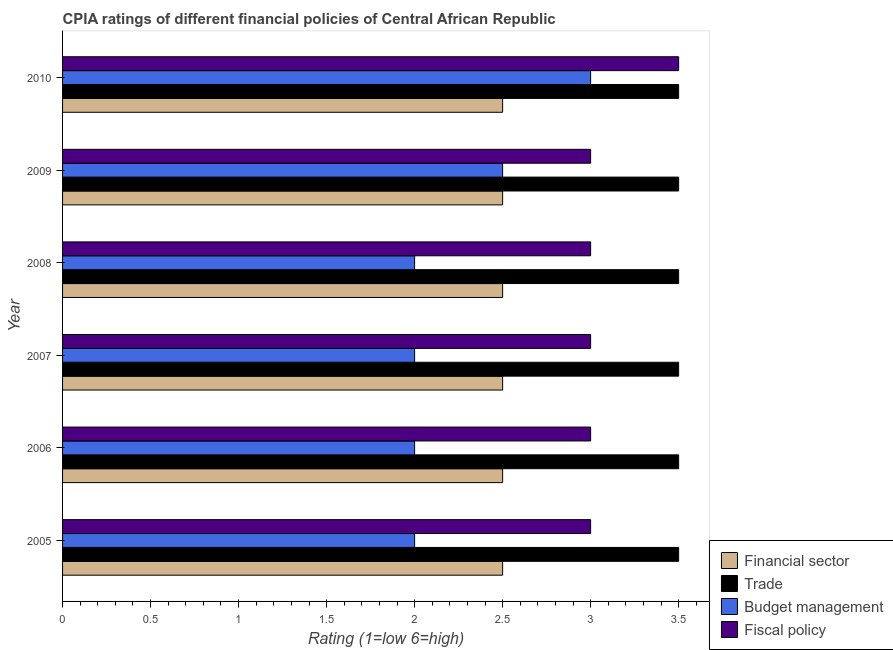How many different coloured bars are there?
Your answer should be compact. 4. Are the number of bars on each tick of the Y-axis equal?
Give a very brief answer. Yes. How many bars are there on the 4th tick from the bottom?
Keep it short and to the point. 4. What is the cpia rating of fiscal policy in 2007?
Ensure brevity in your answer.  3. In which year was the cpia rating of trade minimum?
Make the answer very short. 2005. What is the total cpia rating of trade in the graph?
Your answer should be very brief. 21. What is the difference between the cpia rating of trade in 2009 and the cpia rating of budget management in 2007?
Provide a short and direct response. 1.5. What is the average cpia rating of fiscal policy per year?
Give a very brief answer. 3.08. What is the ratio of the cpia rating of financial sector in 2005 to that in 2007?
Make the answer very short. 1. What is the difference between the highest and the second highest cpia rating of budget management?
Ensure brevity in your answer.  0.5. Is the sum of the cpia rating of trade in 2006 and 2007 greater than the maximum cpia rating of financial sector across all years?
Your answer should be compact. Yes. What does the 2nd bar from the top in 2009 represents?
Give a very brief answer. Budget management. What does the 2nd bar from the bottom in 2007 represents?
Offer a very short reply. Trade. How many bars are there?
Provide a short and direct response. 24. What is the difference between two consecutive major ticks on the X-axis?
Give a very brief answer. 0.5. Where does the legend appear in the graph?
Make the answer very short. Bottom right. How many legend labels are there?
Keep it short and to the point. 4. What is the title of the graph?
Your response must be concise. CPIA ratings of different financial policies of Central African Republic. Does "Secondary vocational" appear as one of the legend labels in the graph?
Give a very brief answer. No. What is the label or title of the Y-axis?
Offer a very short reply. Year. What is the Rating (1=low 6=high) of Trade in 2005?
Ensure brevity in your answer.  3.5. What is the Rating (1=low 6=high) in Fiscal policy in 2005?
Give a very brief answer. 3. What is the Rating (1=low 6=high) in Financial sector in 2006?
Offer a terse response. 2.5. What is the Rating (1=low 6=high) in Trade in 2006?
Offer a terse response. 3.5. What is the Rating (1=low 6=high) of Budget management in 2006?
Give a very brief answer. 2. What is the Rating (1=low 6=high) of Financial sector in 2007?
Offer a terse response. 2.5. What is the Rating (1=low 6=high) in Budget management in 2007?
Keep it short and to the point. 2. What is the Rating (1=low 6=high) in Budget management in 2008?
Offer a terse response. 2. What is the Rating (1=low 6=high) of Fiscal policy in 2009?
Ensure brevity in your answer.  3. What is the Rating (1=low 6=high) in Trade in 2010?
Provide a short and direct response. 3.5. Across all years, what is the maximum Rating (1=low 6=high) in Financial sector?
Provide a short and direct response. 2.5. Across all years, what is the maximum Rating (1=low 6=high) of Budget management?
Provide a succinct answer. 3. Across all years, what is the minimum Rating (1=low 6=high) of Budget management?
Your response must be concise. 2. What is the total Rating (1=low 6=high) in Trade in the graph?
Keep it short and to the point. 21. What is the total Rating (1=low 6=high) in Budget management in the graph?
Your answer should be very brief. 13.5. What is the difference between the Rating (1=low 6=high) of Financial sector in 2005 and that in 2006?
Keep it short and to the point. 0. What is the difference between the Rating (1=low 6=high) of Fiscal policy in 2005 and that in 2006?
Give a very brief answer. 0. What is the difference between the Rating (1=low 6=high) in Financial sector in 2005 and that in 2007?
Provide a succinct answer. 0. What is the difference between the Rating (1=low 6=high) of Trade in 2005 and that in 2007?
Offer a very short reply. 0. What is the difference between the Rating (1=low 6=high) of Budget management in 2005 and that in 2007?
Provide a short and direct response. 0. What is the difference between the Rating (1=low 6=high) of Trade in 2005 and that in 2008?
Provide a short and direct response. 0. What is the difference between the Rating (1=low 6=high) of Budget management in 2005 and that in 2008?
Provide a short and direct response. 0. What is the difference between the Rating (1=low 6=high) of Fiscal policy in 2005 and that in 2008?
Your answer should be very brief. 0. What is the difference between the Rating (1=low 6=high) in Financial sector in 2005 and that in 2010?
Offer a very short reply. 0. What is the difference between the Rating (1=low 6=high) in Budget management in 2005 and that in 2010?
Your answer should be very brief. -1. What is the difference between the Rating (1=low 6=high) in Financial sector in 2006 and that in 2007?
Make the answer very short. 0. What is the difference between the Rating (1=low 6=high) of Budget management in 2006 and that in 2007?
Your response must be concise. 0. What is the difference between the Rating (1=low 6=high) of Fiscal policy in 2006 and that in 2007?
Ensure brevity in your answer.  0. What is the difference between the Rating (1=low 6=high) in Trade in 2006 and that in 2008?
Provide a succinct answer. 0. What is the difference between the Rating (1=low 6=high) of Budget management in 2006 and that in 2008?
Your answer should be compact. 0. What is the difference between the Rating (1=low 6=high) of Trade in 2006 and that in 2009?
Offer a very short reply. 0. What is the difference between the Rating (1=low 6=high) in Budget management in 2006 and that in 2009?
Offer a very short reply. -0.5. What is the difference between the Rating (1=low 6=high) in Financial sector in 2006 and that in 2010?
Make the answer very short. 0. What is the difference between the Rating (1=low 6=high) of Financial sector in 2007 and that in 2008?
Your answer should be very brief. 0. What is the difference between the Rating (1=low 6=high) of Trade in 2007 and that in 2008?
Offer a terse response. 0. What is the difference between the Rating (1=low 6=high) of Budget management in 2007 and that in 2008?
Offer a terse response. 0. What is the difference between the Rating (1=low 6=high) in Trade in 2007 and that in 2009?
Keep it short and to the point. 0. What is the difference between the Rating (1=low 6=high) of Budget management in 2007 and that in 2009?
Keep it short and to the point. -0.5. What is the difference between the Rating (1=low 6=high) in Fiscal policy in 2007 and that in 2009?
Offer a terse response. 0. What is the difference between the Rating (1=low 6=high) of Fiscal policy in 2007 and that in 2010?
Your answer should be very brief. -0.5. What is the difference between the Rating (1=low 6=high) in Trade in 2008 and that in 2009?
Provide a short and direct response. 0. What is the difference between the Rating (1=low 6=high) of Budget management in 2008 and that in 2009?
Your response must be concise. -0.5. What is the difference between the Rating (1=low 6=high) in Fiscal policy in 2008 and that in 2009?
Make the answer very short. 0. What is the difference between the Rating (1=low 6=high) of Financial sector in 2008 and that in 2010?
Offer a very short reply. 0. What is the difference between the Rating (1=low 6=high) of Trade in 2008 and that in 2010?
Ensure brevity in your answer.  0. What is the difference between the Rating (1=low 6=high) in Financial sector in 2009 and that in 2010?
Make the answer very short. 0. What is the difference between the Rating (1=low 6=high) in Trade in 2009 and that in 2010?
Ensure brevity in your answer.  0. What is the difference between the Rating (1=low 6=high) of Budget management in 2009 and that in 2010?
Your answer should be compact. -0.5. What is the difference between the Rating (1=low 6=high) of Fiscal policy in 2009 and that in 2010?
Offer a terse response. -0.5. What is the difference between the Rating (1=low 6=high) in Financial sector in 2005 and the Rating (1=low 6=high) in Budget management in 2006?
Make the answer very short. 0.5. What is the difference between the Rating (1=low 6=high) in Trade in 2005 and the Rating (1=low 6=high) in Fiscal policy in 2006?
Your answer should be very brief. 0.5. What is the difference between the Rating (1=low 6=high) of Trade in 2005 and the Rating (1=low 6=high) of Fiscal policy in 2007?
Give a very brief answer. 0.5. What is the difference between the Rating (1=low 6=high) in Budget management in 2005 and the Rating (1=low 6=high) in Fiscal policy in 2007?
Your answer should be compact. -1. What is the difference between the Rating (1=low 6=high) of Financial sector in 2005 and the Rating (1=low 6=high) of Trade in 2008?
Ensure brevity in your answer.  -1. What is the difference between the Rating (1=low 6=high) of Financial sector in 2005 and the Rating (1=low 6=high) of Fiscal policy in 2008?
Offer a terse response. -0.5. What is the difference between the Rating (1=low 6=high) of Trade in 2005 and the Rating (1=low 6=high) of Budget management in 2008?
Your response must be concise. 1.5. What is the difference between the Rating (1=low 6=high) of Budget management in 2005 and the Rating (1=low 6=high) of Fiscal policy in 2008?
Offer a terse response. -1. What is the difference between the Rating (1=low 6=high) of Financial sector in 2005 and the Rating (1=low 6=high) of Budget management in 2009?
Your response must be concise. 0. What is the difference between the Rating (1=low 6=high) of Financial sector in 2005 and the Rating (1=low 6=high) of Fiscal policy in 2009?
Give a very brief answer. -0.5. What is the difference between the Rating (1=low 6=high) of Trade in 2005 and the Rating (1=low 6=high) of Budget management in 2009?
Your answer should be very brief. 1. What is the difference between the Rating (1=low 6=high) of Budget management in 2005 and the Rating (1=low 6=high) of Fiscal policy in 2009?
Offer a terse response. -1. What is the difference between the Rating (1=low 6=high) of Financial sector in 2005 and the Rating (1=low 6=high) of Fiscal policy in 2010?
Your response must be concise. -1. What is the difference between the Rating (1=low 6=high) of Trade in 2005 and the Rating (1=low 6=high) of Budget management in 2010?
Your response must be concise. 0.5. What is the difference between the Rating (1=low 6=high) of Financial sector in 2006 and the Rating (1=low 6=high) of Trade in 2007?
Provide a succinct answer. -1. What is the difference between the Rating (1=low 6=high) in Financial sector in 2006 and the Rating (1=low 6=high) in Budget management in 2007?
Provide a succinct answer. 0.5. What is the difference between the Rating (1=low 6=high) of Financial sector in 2006 and the Rating (1=low 6=high) of Fiscal policy in 2007?
Your answer should be very brief. -0.5. What is the difference between the Rating (1=low 6=high) in Trade in 2006 and the Rating (1=low 6=high) in Budget management in 2007?
Keep it short and to the point. 1.5. What is the difference between the Rating (1=low 6=high) of Budget management in 2006 and the Rating (1=low 6=high) of Fiscal policy in 2007?
Give a very brief answer. -1. What is the difference between the Rating (1=low 6=high) in Financial sector in 2006 and the Rating (1=low 6=high) in Trade in 2008?
Your answer should be very brief. -1. What is the difference between the Rating (1=low 6=high) in Financial sector in 2006 and the Rating (1=low 6=high) in Budget management in 2008?
Your answer should be compact. 0.5. What is the difference between the Rating (1=low 6=high) of Financial sector in 2006 and the Rating (1=low 6=high) of Fiscal policy in 2008?
Provide a short and direct response. -0.5. What is the difference between the Rating (1=low 6=high) in Trade in 2006 and the Rating (1=low 6=high) in Fiscal policy in 2008?
Your answer should be very brief. 0.5. What is the difference between the Rating (1=low 6=high) of Budget management in 2006 and the Rating (1=low 6=high) of Fiscal policy in 2008?
Your answer should be very brief. -1. What is the difference between the Rating (1=low 6=high) in Trade in 2006 and the Rating (1=low 6=high) in Budget management in 2009?
Ensure brevity in your answer.  1. What is the difference between the Rating (1=low 6=high) of Trade in 2006 and the Rating (1=low 6=high) of Fiscal policy in 2009?
Keep it short and to the point. 0.5. What is the difference between the Rating (1=low 6=high) in Budget management in 2006 and the Rating (1=low 6=high) in Fiscal policy in 2010?
Your response must be concise. -1.5. What is the difference between the Rating (1=low 6=high) in Financial sector in 2007 and the Rating (1=low 6=high) in Trade in 2008?
Give a very brief answer. -1. What is the difference between the Rating (1=low 6=high) in Financial sector in 2007 and the Rating (1=low 6=high) in Budget management in 2008?
Your response must be concise. 0.5. What is the difference between the Rating (1=low 6=high) in Financial sector in 2007 and the Rating (1=low 6=high) in Fiscal policy in 2008?
Offer a very short reply. -0.5. What is the difference between the Rating (1=low 6=high) in Trade in 2007 and the Rating (1=low 6=high) in Budget management in 2008?
Provide a succinct answer. 1.5. What is the difference between the Rating (1=low 6=high) in Trade in 2007 and the Rating (1=low 6=high) in Fiscal policy in 2008?
Provide a succinct answer. 0.5. What is the difference between the Rating (1=low 6=high) of Budget management in 2007 and the Rating (1=low 6=high) of Fiscal policy in 2008?
Offer a terse response. -1. What is the difference between the Rating (1=low 6=high) of Financial sector in 2007 and the Rating (1=low 6=high) of Trade in 2009?
Ensure brevity in your answer.  -1. What is the difference between the Rating (1=low 6=high) of Financial sector in 2007 and the Rating (1=low 6=high) of Budget management in 2009?
Provide a succinct answer. 0. What is the difference between the Rating (1=low 6=high) in Financial sector in 2007 and the Rating (1=low 6=high) in Fiscal policy in 2009?
Make the answer very short. -0.5. What is the difference between the Rating (1=low 6=high) of Trade in 2007 and the Rating (1=low 6=high) of Budget management in 2009?
Offer a terse response. 1. What is the difference between the Rating (1=low 6=high) of Budget management in 2007 and the Rating (1=low 6=high) of Fiscal policy in 2009?
Your answer should be very brief. -1. What is the difference between the Rating (1=low 6=high) in Financial sector in 2007 and the Rating (1=low 6=high) in Trade in 2010?
Ensure brevity in your answer.  -1. What is the difference between the Rating (1=low 6=high) of Financial sector in 2007 and the Rating (1=low 6=high) of Fiscal policy in 2010?
Provide a succinct answer. -1. What is the difference between the Rating (1=low 6=high) of Trade in 2007 and the Rating (1=low 6=high) of Budget management in 2010?
Your answer should be very brief. 0.5. What is the difference between the Rating (1=low 6=high) of Budget management in 2007 and the Rating (1=low 6=high) of Fiscal policy in 2010?
Ensure brevity in your answer.  -1.5. What is the difference between the Rating (1=low 6=high) in Financial sector in 2008 and the Rating (1=low 6=high) in Fiscal policy in 2009?
Make the answer very short. -0.5. What is the difference between the Rating (1=low 6=high) of Trade in 2008 and the Rating (1=low 6=high) of Budget management in 2009?
Give a very brief answer. 1. What is the difference between the Rating (1=low 6=high) in Trade in 2008 and the Rating (1=low 6=high) in Fiscal policy in 2009?
Your response must be concise. 0.5. What is the difference between the Rating (1=low 6=high) in Financial sector in 2008 and the Rating (1=low 6=high) in Trade in 2010?
Give a very brief answer. -1. What is the difference between the Rating (1=low 6=high) of Financial sector in 2008 and the Rating (1=low 6=high) of Budget management in 2010?
Give a very brief answer. -0.5. What is the difference between the Rating (1=low 6=high) of Financial sector in 2008 and the Rating (1=low 6=high) of Fiscal policy in 2010?
Your response must be concise. -1. What is the difference between the Rating (1=low 6=high) of Financial sector in 2009 and the Rating (1=low 6=high) of Budget management in 2010?
Make the answer very short. -0.5. What is the difference between the Rating (1=low 6=high) of Budget management in 2009 and the Rating (1=low 6=high) of Fiscal policy in 2010?
Offer a terse response. -1. What is the average Rating (1=low 6=high) of Trade per year?
Your answer should be compact. 3.5. What is the average Rating (1=low 6=high) of Budget management per year?
Your answer should be very brief. 2.25. What is the average Rating (1=low 6=high) of Fiscal policy per year?
Your response must be concise. 3.08. In the year 2005, what is the difference between the Rating (1=low 6=high) in Financial sector and Rating (1=low 6=high) in Trade?
Ensure brevity in your answer.  -1. In the year 2005, what is the difference between the Rating (1=low 6=high) of Financial sector and Rating (1=low 6=high) of Fiscal policy?
Ensure brevity in your answer.  -0.5. In the year 2005, what is the difference between the Rating (1=low 6=high) of Trade and Rating (1=low 6=high) of Budget management?
Your answer should be very brief. 1.5. In the year 2005, what is the difference between the Rating (1=low 6=high) in Trade and Rating (1=low 6=high) in Fiscal policy?
Offer a very short reply. 0.5. In the year 2005, what is the difference between the Rating (1=low 6=high) in Budget management and Rating (1=low 6=high) in Fiscal policy?
Your response must be concise. -1. In the year 2006, what is the difference between the Rating (1=low 6=high) in Financial sector and Rating (1=low 6=high) in Trade?
Your answer should be compact. -1. In the year 2006, what is the difference between the Rating (1=low 6=high) in Financial sector and Rating (1=low 6=high) in Budget management?
Give a very brief answer. 0.5. In the year 2006, what is the difference between the Rating (1=low 6=high) of Financial sector and Rating (1=low 6=high) of Fiscal policy?
Give a very brief answer. -0.5. In the year 2006, what is the difference between the Rating (1=low 6=high) of Budget management and Rating (1=low 6=high) of Fiscal policy?
Offer a very short reply. -1. In the year 2007, what is the difference between the Rating (1=low 6=high) in Financial sector and Rating (1=low 6=high) in Trade?
Your answer should be very brief. -1. In the year 2007, what is the difference between the Rating (1=low 6=high) of Financial sector and Rating (1=low 6=high) of Budget management?
Keep it short and to the point. 0.5. In the year 2008, what is the difference between the Rating (1=low 6=high) in Financial sector and Rating (1=low 6=high) in Trade?
Offer a very short reply. -1. In the year 2008, what is the difference between the Rating (1=low 6=high) in Financial sector and Rating (1=low 6=high) in Fiscal policy?
Keep it short and to the point. -0.5. In the year 2009, what is the difference between the Rating (1=low 6=high) in Financial sector and Rating (1=low 6=high) in Budget management?
Your response must be concise. 0. In the year 2009, what is the difference between the Rating (1=low 6=high) in Financial sector and Rating (1=low 6=high) in Fiscal policy?
Offer a terse response. -0.5. In the year 2009, what is the difference between the Rating (1=low 6=high) in Trade and Rating (1=low 6=high) in Budget management?
Your response must be concise. 1. In the year 2010, what is the difference between the Rating (1=low 6=high) in Financial sector and Rating (1=low 6=high) in Trade?
Make the answer very short. -1. In the year 2010, what is the difference between the Rating (1=low 6=high) of Financial sector and Rating (1=low 6=high) of Fiscal policy?
Provide a succinct answer. -1. In the year 2010, what is the difference between the Rating (1=low 6=high) of Trade and Rating (1=low 6=high) of Budget management?
Make the answer very short. 0.5. In the year 2010, what is the difference between the Rating (1=low 6=high) in Trade and Rating (1=low 6=high) in Fiscal policy?
Keep it short and to the point. 0. What is the ratio of the Rating (1=low 6=high) of Trade in 2005 to that in 2006?
Ensure brevity in your answer.  1. What is the ratio of the Rating (1=low 6=high) in Fiscal policy in 2005 to that in 2006?
Offer a terse response. 1. What is the ratio of the Rating (1=low 6=high) of Financial sector in 2005 to that in 2007?
Offer a very short reply. 1. What is the ratio of the Rating (1=low 6=high) of Budget management in 2005 to that in 2007?
Your answer should be compact. 1. What is the ratio of the Rating (1=low 6=high) in Financial sector in 2005 to that in 2008?
Your answer should be very brief. 1. What is the ratio of the Rating (1=low 6=high) of Fiscal policy in 2005 to that in 2008?
Your answer should be compact. 1. What is the ratio of the Rating (1=low 6=high) of Budget management in 2005 to that in 2009?
Provide a succinct answer. 0.8. What is the ratio of the Rating (1=low 6=high) of Fiscal policy in 2005 to that in 2009?
Ensure brevity in your answer.  1. What is the ratio of the Rating (1=low 6=high) in Financial sector in 2005 to that in 2010?
Your answer should be compact. 1. What is the ratio of the Rating (1=low 6=high) of Budget management in 2005 to that in 2010?
Provide a short and direct response. 0.67. What is the ratio of the Rating (1=low 6=high) of Fiscal policy in 2005 to that in 2010?
Provide a succinct answer. 0.86. What is the ratio of the Rating (1=low 6=high) in Budget management in 2006 to that in 2007?
Keep it short and to the point. 1. What is the ratio of the Rating (1=low 6=high) in Fiscal policy in 2006 to that in 2007?
Ensure brevity in your answer.  1. What is the ratio of the Rating (1=low 6=high) of Financial sector in 2006 to that in 2008?
Provide a short and direct response. 1. What is the ratio of the Rating (1=low 6=high) in Budget management in 2006 to that in 2008?
Your answer should be very brief. 1. What is the ratio of the Rating (1=low 6=high) in Trade in 2006 to that in 2009?
Give a very brief answer. 1. What is the ratio of the Rating (1=low 6=high) of Budget management in 2006 to that in 2009?
Your answer should be very brief. 0.8. What is the ratio of the Rating (1=low 6=high) of Fiscal policy in 2006 to that in 2009?
Your answer should be very brief. 1. What is the ratio of the Rating (1=low 6=high) of Financial sector in 2006 to that in 2010?
Give a very brief answer. 1. What is the ratio of the Rating (1=low 6=high) of Trade in 2006 to that in 2010?
Your answer should be very brief. 1. What is the ratio of the Rating (1=low 6=high) in Budget management in 2006 to that in 2010?
Your answer should be compact. 0.67. What is the ratio of the Rating (1=low 6=high) of Fiscal policy in 2006 to that in 2010?
Give a very brief answer. 0.86. What is the ratio of the Rating (1=low 6=high) of Budget management in 2007 to that in 2008?
Keep it short and to the point. 1. What is the ratio of the Rating (1=low 6=high) in Trade in 2007 to that in 2009?
Your answer should be compact. 1. What is the ratio of the Rating (1=low 6=high) in Fiscal policy in 2007 to that in 2009?
Provide a short and direct response. 1. What is the ratio of the Rating (1=low 6=high) in Trade in 2008 to that in 2009?
Offer a very short reply. 1. What is the ratio of the Rating (1=low 6=high) of Fiscal policy in 2008 to that in 2009?
Your response must be concise. 1. What is the ratio of the Rating (1=low 6=high) of Budget management in 2008 to that in 2010?
Your response must be concise. 0.67. What is the ratio of the Rating (1=low 6=high) of Financial sector in 2009 to that in 2010?
Your response must be concise. 1. What is the ratio of the Rating (1=low 6=high) of Budget management in 2009 to that in 2010?
Offer a very short reply. 0.83. What is the ratio of the Rating (1=low 6=high) in Fiscal policy in 2009 to that in 2010?
Your answer should be very brief. 0.86. What is the difference between the highest and the second highest Rating (1=low 6=high) in Financial sector?
Keep it short and to the point. 0. What is the difference between the highest and the lowest Rating (1=low 6=high) in Financial sector?
Your answer should be compact. 0. 